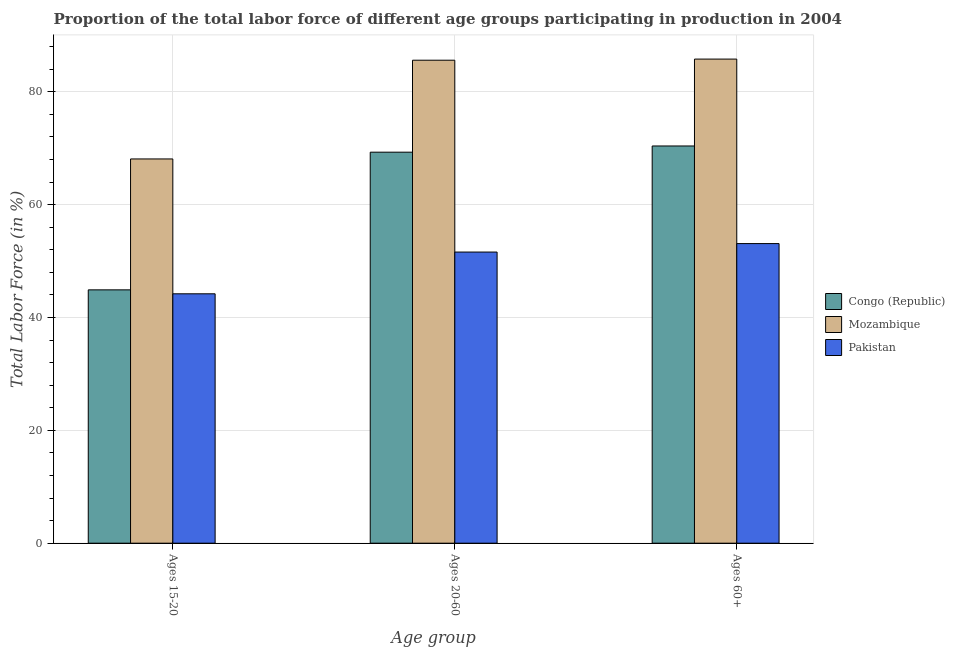How many different coloured bars are there?
Offer a very short reply. 3. Are the number of bars per tick equal to the number of legend labels?
Offer a terse response. Yes. How many bars are there on the 1st tick from the left?
Provide a succinct answer. 3. What is the label of the 2nd group of bars from the left?
Provide a succinct answer. Ages 20-60. What is the percentage of labor force within the age group 20-60 in Congo (Republic)?
Make the answer very short. 69.3. Across all countries, what is the maximum percentage of labor force above age 60?
Your answer should be very brief. 85.8. Across all countries, what is the minimum percentage of labor force within the age group 15-20?
Offer a terse response. 44.2. In which country was the percentage of labor force above age 60 maximum?
Offer a terse response. Mozambique. In which country was the percentage of labor force within the age group 20-60 minimum?
Your response must be concise. Pakistan. What is the total percentage of labor force within the age group 15-20 in the graph?
Offer a terse response. 157.2. What is the difference between the percentage of labor force above age 60 in Pakistan and that in Mozambique?
Your response must be concise. -32.7. What is the difference between the percentage of labor force above age 60 in Congo (Republic) and the percentage of labor force within the age group 15-20 in Mozambique?
Your answer should be very brief. 2.3. What is the average percentage of labor force within the age group 15-20 per country?
Your answer should be very brief. 52.4. What is the difference between the percentage of labor force within the age group 15-20 and percentage of labor force above age 60 in Mozambique?
Give a very brief answer. -17.7. In how many countries, is the percentage of labor force above age 60 greater than 16 %?
Keep it short and to the point. 3. What is the ratio of the percentage of labor force within the age group 20-60 in Congo (Republic) to that in Mozambique?
Your answer should be compact. 0.81. What is the difference between the highest and the second highest percentage of labor force above age 60?
Ensure brevity in your answer.  15.4. What is the difference between the highest and the lowest percentage of labor force above age 60?
Offer a very short reply. 32.7. What does the 1st bar from the left in Ages 20-60 represents?
Provide a succinct answer. Congo (Republic). Is it the case that in every country, the sum of the percentage of labor force within the age group 15-20 and percentage of labor force within the age group 20-60 is greater than the percentage of labor force above age 60?
Keep it short and to the point. Yes. How many bars are there?
Give a very brief answer. 9. Are all the bars in the graph horizontal?
Provide a short and direct response. No. What is the difference between two consecutive major ticks on the Y-axis?
Keep it short and to the point. 20. Does the graph contain any zero values?
Your response must be concise. No. Does the graph contain grids?
Keep it short and to the point. Yes. Where does the legend appear in the graph?
Your response must be concise. Center right. How many legend labels are there?
Ensure brevity in your answer.  3. How are the legend labels stacked?
Provide a succinct answer. Vertical. What is the title of the graph?
Ensure brevity in your answer.  Proportion of the total labor force of different age groups participating in production in 2004. What is the label or title of the X-axis?
Offer a very short reply. Age group. What is the label or title of the Y-axis?
Offer a very short reply. Total Labor Force (in %). What is the Total Labor Force (in %) in Congo (Republic) in Ages 15-20?
Give a very brief answer. 44.9. What is the Total Labor Force (in %) in Mozambique in Ages 15-20?
Your response must be concise. 68.1. What is the Total Labor Force (in %) of Pakistan in Ages 15-20?
Give a very brief answer. 44.2. What is the Total Labor Force (in %) in Congo (Republic) in Ages 20-60?
Keep it short and to the point. 69.3. What is the Total Labor Force (in %) in Mozambique in Ages 20-60?
Offer a very short reply. 85.6. What is the Total Labor Force (in %) in Pakistan in Ages 20-60?
Make the answer very short. 51.6. What is the Total Labor Force (in %) of Congo (Republic) in Ages 60+?
Keep it short and to the point. 70.4. What is the Total Labor Force (in %) in Mozambique in Ages 60+?
Give a very brief answer. 85.8. What is the Total Labor Force (in %) in Pakistan in Ages 60+?
Your answer should be compact. 53.1. Across all Age group, what is the maximum Total Labor Force (in %) in Congo (Republic)?
Ensure brevity in your answer.  70.4. Across all Age group, what is the maximum Total Labor Force (in %) in Mozambique?
Keep it short and to the point. 85.8. Across all Age group, what is the maximum Total Labor Force (in %) of Pakistan?
Make the answer very short. 53.1. Across all Age group, what is the minimum Total Labor Force (in %) of Congo (Republic)?
Give a very brief answer. 44.9. Across all Age group, what is the minimum Total Labor Force (in %) of Mozambique?
Offer a very short reply. 68.1. Across all Age group, what is the minimum Total Labor Force (in %) of Pakistan?
Keep it short and to the point. 44.2. What is the total Total Labor Force (in %) in Congo (Republic) in the graph?
Provide a short and direct response. 184.6. What is the total Total Labor Force (in %) of Mozambique in the graph?
Give a very brief answer. 239.5. What is the total Total Labor Force (in %) of Pakistan in the graph?
Keep it short and to the point. 148.9. What is the difference between the Total Labor Force (in %) in Congo (Republic) in Ages 15-20 and that in Ages 20-60?
Your answer should be compact. -24.4. What is the difference between the Total Labor Force (in %) of Mozambique in Ages 15-20 and that in Ages 20-60?
Your answer should be very brief. -17.5. What is the difference between the Total Labor Force (in %) of Pakistan in Ages 15-20 and that in Ages 20-60?
Ensure brevity in your answer.  -7.4. What is the difference between the Total Labor Force (in %) in Congo (Republic) in Ages 15-20 and that in Ages 60+?
Make the answer very short. -25.5. What is the difference between the Total Labor Force (in %) in Mozambique in Ages 15-20 and that in Ages 60+?
Offer a very short reply. -17.7. What is the difference between the Total Labor Force (in %) of Pakistan in Ages 15-20 and that in Ages 60+?
Your answer should be very brief. -8.9. What is the difference between the Total Labor Force (in %) of Mozambique in Ages 20-60 and that in Ages 60+?
Your answer should be very brief. -0.2. What is the difference between the Total Labor Force (in %) in Pakistan in Ages 20-60 and that in Ages 60+?
Make the answer very short. -1.5. What is the difference between the Total Labor Force (in %) in Congo (Republic) in Ages 15-20 and the Total Labor Force (in %) in Mozambique in Ages 20-60?
Give a very brief answer. -40.7. What is the difference between the Total Labor Force (in %) in Mozambique in Ages 15-20 and the Total Labor Force (in %) in Pakistan in Ages 20-60?
Your answer should be very brief. 16.5. What is the difference between the Total Labor Force (in %) in Congo (Republic) in Ages 15-20 and the Total Labor Force (in %) in Mozambique in Ages 60+?
Provide a succinct answer. -40.9. What is the difference between the Total Labor Force (in %) in Congo (Republic) in Ages 15-20 and the Total Labor Force (in %) in Pakistan in Ages 60+?
Offer a terse response. -8.2. What is the difference between the Total Labor Force (in %) in Mozambique in Ages 15-20 and the Total Labor Force (in %) in Pakistan in Ages 60+?
Ensure brevity in your answer.  15. What is the difference between the Total Labor Force (in %) in Congo (Republic) in Ages 20-60 and the Total Labor Force (in %) in Mozambique in Ages 60+?
Provide a succinct answer. -16.5. What is the difference between the Total Labor Force (in %) in Mozambique in Ages 20-60 and the Total Labor Force (in %) in Pakistan in Ages 60+?
Ensure brevity in your answer.  32.5. What is the average Total Labor Force (in %) in Congo (Republic) per Age group?
Your answer should be very brief. 61.53. What is the average Total Labor Force (in %) in Mozambique per Age group?
Offer a very short reply. 79.83. What is the average Total Labor Force (in %) of Pakistan per Age group?
Make the answer very short. 49.63. What is the difference between the Total Labor Force (in %) in Congo (Republic) and Total Labor Force (in %) in Mozambique in Ages 15-20?
Provide a short and direct response. -23.2. What is the difference between the Total Labor Force (in %) in Mozambique and Total Labor Force (in %) in Pakistan in Ages 15-20?
Offer a very short reply. 23.9. What is the difference between the Total Labor Force (in %) of Congo (Republic) and Total Labor Force (in %) of Mozambique in Ages 20-60?
Give a very brief answer. -16.3. What is the difference between the Total Labor Force (in %) in Congo (Republic) and Total Labor Force (in %) in Pakistan in Ages 20-60?
Offer a very short reply. 17.7. What is the difference between the Total Labor Force (in %) in Congo (Republic) and Total Labor Force (in %) in Mozambique in Ages 60+?
Give a very brief answer. -15.4. What is the difference between the Total Labor Force (in %) of Congo (Republic) and Total Labor Force (in %) of Pakistan in Ages 60+?
Offer a terse response. 17.3. What is the difference between the Total Labor Force (in %) of Mozambique and Total Labor Force (in %) of Pakistan in Ages 60+?
Your response must be concise. 32.7. What is the ratio of the Total Labor Force (in %) of Congo (Republic) in Ages 15-20 to that in Ages 20-60?
Give a very brief answer. 0.65. What is the ratio of the Total Labor Force (in %) of Mozambique in Ages 15-20 to that in Ages 20-60?
Provide a short and direct response. 0.8. What is the ratio of the Total Labor Force (in %) of Pakistan in Ages 15-20 to that in Ages 20-60?
Your answer should be compact. 0.86. What is the ratio of the Total Labor Force (in %) in Congo (Republic) in Ages 15-20 to that in Ages 60+?
Your response must be concise. 0.64. What is the ratio of the Total Labor Force (in %) in Mozambique in Ages 15-20 to that in Ages 60+?
Provide a succinct answer. 0.79. What is the ratio of the Total Labor Force (in %) in Pakistan in Ages 15-20 to that in Ages 60+?
Offer a very short reply. 0.83. What is the ratio of the Total Labor Force (in %) of Congo (Republic) in Ages 20-60 to that in Ages 60+?
Your answer should be very brief. 0.98. What is the ratio of the Total Labor Force (in %) in Mozambique in Ages 20-60 to that in Ages 60+?
Ensure brevity in your answer.  1. What is the ratio of the Total Labor Force (in %) in Pakistan in Ages 20-60 to that in Ages 60+?
Your response must be concise. 0.97. What is the difference between the highest and the lowest Total Labor Force (in %) of Congo (Republic)?
Your answer should be very brief. 25.5. What is the difference between the highest and the lowest Total Labor Force (in %) of Mozambique?
Keep it short and to the point. 17.7. What is the difference between the highest and the lowest Total Labor Force (in %) of Pakistan?
Your response must be concise. 8.9. 